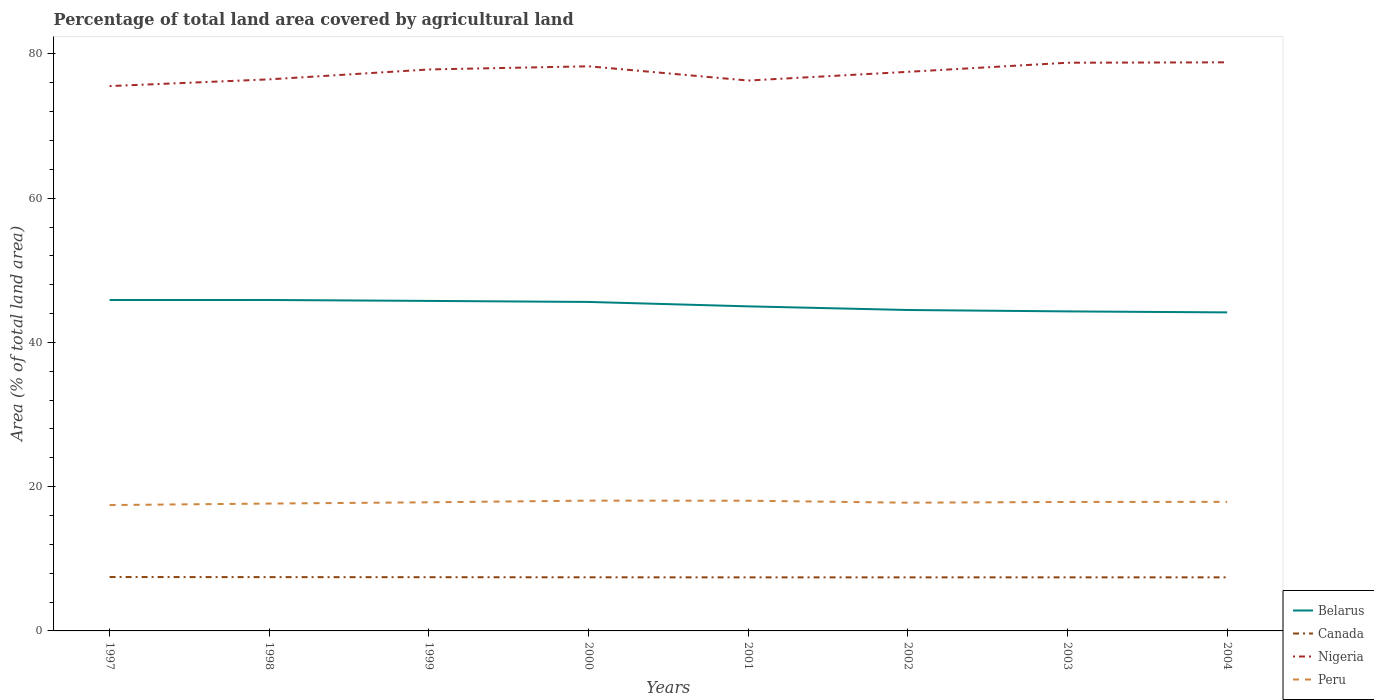Does the line corresponding to Canada intersect with the line corresponding to Peru?
Keep it short and to the point. No. Is the number of lines equal to the number of legend labels?
Keep it short and to the point. Yes. Across all years, what is the maximum percentage of agricultural land in Nigeria?
Offer a terse response. 75.54. What is the total percentage of agricultural land in Canada in the graph?
Provide a short and direct response. 0.04. What is the difference between the highest and the second highest percentage of agricultural land in Canada?
Make the answer very short. 0.05. Is the percentage of agricultural land in Peru strictly greater than the percentage of agricultural land in Canada over the years?
Make the answer very short. No. What is the difference between two consecutive major ticks on the Y-axis?
Your answer should be compact. 20. Are the values on the major ticks of Y-axis written in scientific E-notation?
Your answer should be very brief. No. What is the title of the graph?
Your answer should be very brief. Percentage of total land area covered by agricultural land. What is the label or title of the Y-axis?
Your answer should be compact. Area (% of total land area). What is the Area (% of total land area) of Belarus in 1997?
Offer a very short reply. 45.88. What is the Area (% of total land area) in Canada in 1997?
Make the answer very short. 7.47. What is the Area (% of total land area) of Nigeria in 1997?
Provide a short and direct response. 75.54. What is the Area (% of total land area) of Peru in 1997?
Give a very brief answer. 17.45. What is the Area (% of total land area) of Belarus in 1998?
Provide a succinct answer. 45.88. What is the Area (% of total land area) of Canada in 1998?
Your answer should be compact. 7.46. What is the Area (% of total land area) of Nigeria in 1998?
Give a very brief answer. 76.47. What is the Area (% of total land area) of Peru in 1998?
Ensure brevity in your answer.  17.66. What is the Area (% of total land area) of Belarus in 1999?
Ensure brevity in your answer.  45.76. What is the Area (% of total land area) of Canada in 1999?
Make the answer very short. 7.45. What is the Area (% of total land area) in Nigeria in 1999?
Your answer should be very brief. 77.85. What is the Area (% of total land area) in Peru in 1999?
Provide a succinct answer. 17.83. What is the Area (% of total land area) of Belarus in 2000?
Make the answer very short. 45.61. What is the Area (% of total land area) of Canada in 2000?
Your answer should be very brief. 7.44. What is the Area (% of total land area) of Nigeria in 2000?
Provide a succinct answer. 78.29. What is the Area (% of total land area) of Peru in 2000?
Your response must be concise. 18.07. What is the Area (% of total land area) of Belarus in 2001?
Make the answer very short. 45. What is the Area (% of total land area) in Canada in 2001?
Offer a terse response. 7.42. What is the Area (% of total land area) of Nigeria in 2001?
Make the answer very short. 76.31. What is the Area (% of total land area) in Peru in 2001?
Your answer should be compact. 18.05. What is the Area (% of total land area) in Belarus in 2002?
Give a very brief answer. 44.5. What is the Area (% of total land area) in Canada in 2002?
Provide a short and direct response. 7.42. What is the Area (% of total land area) in Nigeria in 2002?
Your response must be concise. 77.52. What is the Area (% of total land area) of Peru in 2002?
Offer a very short reply. 17.78. What is the Area (% of total land area) of Belarus in 2003?
Your response must be concise. 44.3. What is the Area (% of total land area) in Canada in 2003?
Keep it short and to the point. 7.43. What is the Area (% of total land area) of Nigeria in 2003?
Make the answer very short. 78.78. What is the Area (% of total land area) of Peru in 2003?
Give a very brief answer. 17.88. What is the Area (% of total land area) of Belarus in 2004?
Provide a short and direct response. 44.16. What is the Area (% of total land area) in Canada in 2004?
Provide a short and direct response. 7.43. What is the Area (% of total land area) in Nigeria in 2004?
Offer a terse response. 78.83. What is the Area (% of total land area) in Peru in 2004?
Make the answer very short. 17.9. Across all years, what is the maximum Area (% of total land area) of Belarus?
Provide a succinct answer. 45.88. Across all years, what is the maximum Area (% of total land area) of Canada?
Offer a terse response. 7.47. Across all years, what is the maximum Area (% of total land area) in Nigeria?
Offer a very short reply. 78.83. Across all years, what is the maximum Area (% of total land area) in Peru?
Keep it short and to the point. 18.07. Across all years, what is the minimum Area (% of total land area) in Belarus?
Ensure brevity in your answer.  44.16. Across all years, what is the minimum Area (% of total land area) of Canada?
Your answer should be very brief. 7.42. Across all years, what is the minimum Area (% of total land area) in Nigeria?
Your answer should be very brief. 75.54. Across all years, what is the minimum Area (% of total land area) of Peru?
Your answer should be very brief. 17.45. What is the total Area (% of total land area) in Belarus in the graph?
Offer a terse response. 361.09. What is the total Area (% of total land area) in Canada in the graph?
Give a very brief answer. 59.52. What is the total Area (% of total land area) of Nigeria in the graph?
Provide a succinct answer. 619.59. What is the total Area (% of total land area) of Peru in the graph?
Your response must be concise. 142.61. What is the difference between the Area (% of total land area) in Belarus in 1997 and that in 1998?
Keep it short and to the point. -0. What is the difference between the Area (% of total land area) of Canada in 1997 and that in 1998?
Provide a succinct answer. 0.01. What is the difference between the Area (% of total land area) in Nigeria in 1997 and that in 1998?
Offer a terse response. -0.93. What is the difference between the Area (% of total land area) in Peru in 1997 and that in 1998?
Offer a terse response. -0.21. What is the difference between the Area (% of total land area) in Belarus in 1997 and that in 1999?
Give a very brief answer. 0.12. What is the difference between the Area (% of total land area) of Canada in 1997 and that in 1999?
Offer a very short reply. 0.02. What is the difference between the Area (% of total land area) of Nigeria in 1997 and that in 1999?
Make the answer very short. -2.31. What is the difference between the Area (% of total land area) in Peru in 1997 and that in 1999?
Provide a succinct answer. -0.38. What is the difference between the Area (% of total land area) in Belarus in 1997 and that in 2000?
Offer a very short reply. 0.27. What is the difference between the Area (% of total land area) in Canada in 1997 and that in 2000?
Ensure brevity in your answer.  0.04. What is the difference between the Area (% of total land area) in Nigeria in 1997 and that in 2000?
Give a very brief answer. -2.74. What is the difference between the Area (% of total land area) of Peru in 1997 and that in 2000?
Give a very brief answer. -0.62. What is the difference between the Area (% of total land area) in Belarus in 1997 and that in 2001?
Ensure brevity in your answer.  0.88. What is the difference between the Area (% of total land area) in Canada in 1997 and that in 2001?
Your response must be concise. 0.05. What is the difference between the Area (% of total land area) in Nigeria in 1997 and that in 2001?
Provide a succinct answer. -0.77. What is the difference between the Area (% of total land area) in Peru in 1997 and that in 2001?
Offer a terse response. -0.6. What is the difference between the Area (% of total land area) of Belarus in 1997 and that in 2002?
Make the answer very short. 1.38. What is the difference between the Area (% of total land area) of Canada in 1997 and that in 2002?
Ensure brevity in your answer.  0.05. What is the difference between the Area (% of total land area) of Nigeria in 1997 and that in 2002?
Your response must be concise. -1.98. What is the difference between the Area (% of total land area) in Peru in 1997 and that in 2002?
Provide a short and direct response. -0.33. What is the difference between the Area (% of total land area) of Belarus in 1997 and that in 2003?
Offer a very short reply. 1.58. What is the difference between the Area (% of total land area) of Canada in 1997 and that in 2003?
Provide a short and direct response. 0.04. What is the difference between the Area (% of total land area) in Nigeria in 1997 and that in 2003?
Make the answer very short. -3.24. What is the difference between the Area (% of total land area) of Peru in 1997 and that in 2003?
Your answer should be very brief. -0.43. What is the difference between the Area (% of total land area) of Belarus in 1997 and that in 2004?
Give a very brief answer. 1.71. What is the difference between the Area (% of total land area) of Canada in 1997 and that in 2004?
Your response must be concise. 0.04. What is the difference between the Area (% of total land area) of Nigeria in 1997 and that in 2004?
Your response must be concise. -3.29. What is the difference between the Area (% of total land area) in Peru in 1997 and that in 2004?
Give a very brief answer. -0.45. What is the difference between the Area (% of total land area) in Belarus in 1998 and that in 1999?
Your answer should be very brief. 0.13. What is the difference between the Area (% of total land area) of Canada in 1998 and that in 1999?
Make the answer very short. 0.01. What is the difference between the Area (% of total land area) of Nigeria in 1998 and that in 1999?
Keep it short and to the point. -1.37. What is the difference between the Area (% of total land area) of Peru in 1998 and that in 1999?
Make the answer very short. -0.17. What is the difference between the Area (% of total land area) in Belarus in 1998 and that in 2000?
Your response must be concise. 0.27. What is the difference between the Area (% of total land area) of Canada in 1998 and that in 2000?
Make the answer very short. 0.02. What is the difference between the Area (% of total land area) in Nigeria in 1998 and that in 2000?
Keep it short and to the point. -1.81. What is the difference between the Area (% of total land area) of Peru in 1998 and that in 2000?
Provide a succinct answer. -0.41. What is the difference between the Area (% of total land area) of Belarus in 1998 and that in 2001?
Provide a short and direct response. 0.88. What is the difference between the Area (% of total land area) in Canada in 1998 and that in 2001?
Give a very brief answer. 0.04. What is the difference between the Area (% of total land area) in Nigeria in 1998 and that in 2001?
Provide a short and direct response. 0.16. What is the difference between the Area (% of total land area) in Peru in 1998 and that in 2001?
Your answer should be compact. -0.39. What is the difference between the Area (% of total land area) of Belarus in 1998 and that in 2002?
Keep it short and to the point. 1.39. What is the difference between the Area (% of total land area) in Canada in 1998 and that in 2002?
Give a very brief answer. 0.03. What is the difference between the Area (% of total land area) of Nigeria in 1998 and that in 2002?
Your answer should be very brief. -1.04. What is the difference between the Area (% of total land area) in Peru in 1998 and that in 2002?
Ensure brevity in your answer.  -0.12. What is the difference between the Area (% of total land area) of Belarus in 1998 and that in 2003?
Your answer should be very brief. 1.58. What is the difference between the Area (% of total land area) of Canada in 1998 and that in 2003?
Provide a short and direct response. 0.03. What is the difference between the Area (% of total land area) of Nigeria in 1998 and that in 2003?
Ensure brevity in your answer.  -2.31. What is the difference between the Area (% of total land area) in Peru in 1998 and that in 2003?
Your answer should be compact. -0.22. What is the difference between the Area (% of total land area) of Belarus in 1998 and that in 2004?
Provide a short and direct response. 1.72. What is the difference between the Area (% of total land area) of Canada in 1998 and that in 2004?
Provide a short and direct response. 0.03. What is the difference between the Area (% of total land area) in Nigeria in 1998 and that in 2004?
Give a very brief answer. -2.36. What is the difference between the Area (% of total land area) of Peru in 1998 and that in 2004?
Your answer should be compact. -0.24. What is the difference between the Area (% of total land area) of Belarus in 1999 and that in 2000?
Provide a short and direct response. 0.14. What is the difference between the Area (% of total land area) in Canada in 1999 and that in 2000?
Make the answer very short. 0.01. What is the difference between the Area (% of total land area) of Nigeria in 1999 and that in 2000?
Ensure brevity in your answer.  -0.44. What is the difference between the Area (% of total land area) in Peru in 1999 and that in 2000?
Provide a short and direct response. -0.23. What is the difference between the Area (% of total land area) of Belarus in 1999 and that in 2001?
Keep it short and to the point. 0.75. What is the difference between the Area (% of total land area) of Canada in 1999 and that in 2001?
Your answer should be compact. 0.02. What is the difference between the Area (% of total land area) of Nigeria in 1999 and that in 2001?
Your answer should be compact. 1.54. What is the difference between the Area (% of total land area) of Peru in 1999 and that in 2001?
Provide a succinct answer. -0.22. What is the difference between the Area (% of total land area) of Belarus in 1999 and that in 2002?
Provide a succinct answer. 1.26. What is the difference between the Area (% of total land area) of Canada in 1999 and that in 2002?
Offer a terse response. 0.02. What is the difference between the Area (% of total land area) in Nigeria in 1999 and that in 2002?
Offer a very short reply. 0.33. What is the difference between the Area (% of total land area) in Peru in 1999 and that in 2002?
Your response must be concise. 0.06. What is the difference between the Area (% of total land area) of Belarus in 1999 and that in 2003?
Your answer should be compact. 1.45. What is the difference between the Area (% of total land area) of Canada in 1999 and that in 2003?
Your answer should be compact. 0.02. What is the difference between the Area (% of total land area) of Nigeria in 1999 and that in 2003?
Give a very brief answer. -0.93. What is the difference between the Area (% of total land area) in Peru in 1999 and that in 2003?
Ensure brevity in your answer.  -0.05. What is the difference between the Area (% of total land area) in Belarus in 1999 and that in 2004?
Ensure brevity in your answer.  1.59. What is the difference between the Area (% of total land area) in Canada in 1999 and that in 2004?
Make the answer very short. 0.02. What is the difference between the Area (% of total land area) of Nigeria in 1999 and that in 2004?
Your answer should be compact. -0.99. What is the difference between the Area (% of total land area) in Peru in 1999 and that in 2004?
Offer a very short reply. -0.06. What is the difference between the Area (% of total land area) in Belarus in 2000 and that in 2001?
Offer a very short reply. 0.61. What is the difference between the Area (% of total land area) in Canada in 2000 and that in 2001?
Your answer should be very brief. 0.01. What is the difference between the Area (% of total land area) of Nigeria in 2000 and that in 2001?
Make the answer very short. 1.98. What is the difference between the Area (% of total land area) of Peru in 2000 and that in 2001?
Your answer should be very brief. 0.01. What is the difference between the Area (% of total land area) in Belarus in 2000 and that in 2002?
Provide a short and direct response. 1.12. What is the difference between the Area (% of total land area) in Canada in 2000 and that in 2002?
Give a very brief answer. 0.01. What is the difference between the Area (% of total land area) of Nigeria in 2000 and that in 2002?
Your answer should be compact. 0.77. What is the difference between the Area (% of total land area) in Peru in 2000 and that in 2002?
Your answer should be very brief. 0.29. What is the difference between the Area (% of total land area) of Belarus in 2000 and that in 2003?
Give a very brief answer. 1.31. What is the difference between the Area (% of total land area) of Canada in 2000 and that in 2003?
Give a very brief answer. 0.01. What is the difference between the Area (% of total land area) in Nigeria in 2000 and that in 2003?
Provide a short and direct response. -0.49. What is the difference between the Area (% of total land area) of Peru in 2000 and that in 2003?
Provide a short and direct response. 0.18. What is the difference between the Area (% of total land area) of Belarus in 2000 and that in 2004?
Your answer should be compact. 1.45. What is the difference between the Area (% of total land area) in Canada in 2000 and that in 2004?
Give a very brief answer. 0.01. What is the difference between the Area (% of total land area) in Nigeria in 2000 and that in 2004?
Make the answer very short. -0.55. What is the difference between the Area (% of total land area) of Peru in 2000 and that in 2004?
Make the answer very short. 0.17. What is the difference between the Area (% of total land area) in Belarus in 2001 and that in 2002?
Your answer should be compact. 0.51. What is the difference between the Area (% of total land area) of Canada in 2001 and that in 2002?
Offer a very short reply. -0. What is the difference between the Area (% of total land area) in Nigeria in 2001 and that in 2002?
Your answer should be very brief. -1.21. What is the difference between the Area (% of total land area) of Peru in 2001 and that in 2002?
Your answer should be compact. 0.28. What is the difference between the Area (% of total land area) of Belarus in 2001 and that in 2003?
Offer a terse response. 0.7. What is the difference between the Area (% of total land area) in Canada in 2001 and that in 2003?
Provide a short and direct response. -0. What is the difference between the Area (% of total land area) of Nigeria in 2001 and that in 2003?
Offer a terse response. -2.47. What is the difference between the Area (% of total land area) in Peru in 2001 and that in 2003?
Your response must be concise. 0.17. What is the difference between the Area (% of total land area) in Belarus in 2001 and that in 2004?
Offer a very short reply. 0.84. What is the difference between the Area (% of total land area) of Canada in 2001 and that in 2004?
Keep it short and to the point. -0.01. What is the difference between the Area (% of total land area) in Nigeria in 2001 and that in 2004?
Ensure brevity in your answer.  -2.53. What is the difference between the Area (% of total land area) of Peru in 2001 and that in 2004?
Your answer should be compact. 0.16. What is the difference between the Area (% of total land area) of Belarus in 2002 and that in 2003?
Provide a succinct answer. 0.19. What is the difference between the Area (% of total land area) of Canada in 2002 and that in 2003?
Make the answer very short. -0. What is the difference between the Area (% of total land area) in Nigeria in 2002 and that in 2003?
Provide a succinct answer. -1.26. What is the difference between the Area (% of total land area) of Peru in 2002 and that in 2003?
Your answer should be compact. -0.1. What is the difference between the Area (% of total land area) of Belarus in 2002 and that in 2004?
Your response must be concise. 0.33. What is the difference between the Area (% of total land area) in Canada in 2002 and that in 2004?
Keep it short and to the point. -0. What is the difference between the Area (% of total land area) in Nigeria in 2002 and that in 2004?
Your answer should be very brief. -1.32. What is the difference between the Area (% of total land area) of Peru in 2002 and that in 2004?
Provide a short and direct response. -0.12. What is the difference between the Area (% of total land area) of Belarus in 2003 and that in 2004?
Your response must be concise. 0.14. What is the difference between the Area (% of total land area) of Canada in 2003 and that in 2004?
Offer a terse response. -0. What is the difference between the Area (% of total land area) of Nigeria in 2003 and that in 2004?
Your answer should be very brief. -0.05. What is the difference between the Area (% of total land area) in Peru in 2003 and that in 2004?
Offer a terse response. -0.01. What is the difference between the Area (% of total land area) in Belarus in 1997 and the Area (% of total land area) in Canada in 1998?
Your answer should be compact. 38.42. What is the difference between the Area (% of total land area) in Belarus in 1997 and the Area (% of total land area) in Nigeria in 1998?
Provide a succinct answer. -30.6. What is the difference between the Area (% of total land area) in Belarus in 1997 and the Area (% of total land area) in Peru in 1998?
Your answer should be compact. 28.22. What is the difference between the Area (% of total land area) of Canada in 1997 and the Area (% of total land area) of Nigeria in 1998?
Your answer should be compact. -69. What is the difference between the Area (% of total land area) in Canada in 1997 and the Area (% of total land area) in Peru in 1998?
Make the answer very short. -10.19. What is the difference between the Area (% of total land area) in Nigeria in 1997 and the Area (% of total land area) in Peru in 1998?
Give a very brief answer. 57.88. What is the difference between the Area (% of total land area) in Belarus in 1997 and the Area (% of total land area) in Canada in 1999?
Make the answer very short. 38.43. What is the difference between the Area (% of total land area) of Belarus in 1997 and the Area (% of total land area) of Nigeria in 1999?
Make the answer very short. -31.97. What is the difference between the Area (% of total land area) in Belarus in 1997 and the Area (% of total land area) in Peru in 1999?
Your answer should be very brief. 28.05. What is the difference between the Area (% of total land area) of Canada in 1997 and the Area (% of total land area) of Nigeria in 1999?
Offer a very short reply. -70.37. What is the difference between the Area (% of total land area) of Canada in 1997 and the Area (% of total land area) of Peru in 1999?
Keep it short and to the point. -10.36. What is the difference between the Area (% of total land area) in Nigeria in 1997 and the Area (% of total land area) in Peru in 1999?
Offer a terse response. 57.71. What is the difference between the Area (% of total land area) in Belarus in 1997 and the Area (% of total land area) in Canada in 2000?
Provide a short and direct response. 38.44. What is the difference between the Area (% of total land area) of Belarus in 1997 and the Area (% of total land area) of Nigeria in 2000?
Offer a terse response. -32.41. What is the difference between the Area (% of total land area) of Belarus in 1997 and the Area (% of total land area) of Peru in 2000?
Your answer should be compact. 27.81. What is the difference between the Area (% of total land area) in Canada in 1997 and the Area (% of total land area) in Nigeria in 2000?
Give a very brief answer. -70.81. What is the difference between the Area (% of total land area) in Canada in 1997 and the Area (% of total land area) in Peru in 2000?
Provide a succinct answer. -10.59. What is the difference between the Area (% of total land area) of Nigeria in 1997 and the Area (% of total land area) of Peru in 2000?
Offer a very short reply. 57.47. What is the difference between the Area (% of total land area) in Belarus in 1997 and the Area (% of total land area) in Canada in 2001?
Your response must be concise. 38.46. What is the difference between the Area (% of total land area) of Belarus in 1997 and the Area (% of total land area) of Nigeria in 2001?
Provide a succinct answer. -30.43. What is the difference between the Area (% of total land area) of Belarus in 1997 and the Area (% of total land area) of Peru in 2001?
Give a very brief answer. 27.83. What is the difference between the Area (% of total land area) in Canada in 1997 and the Area (% of total land area) in Nigeria in 2001?
Your response must be concise. -68.84. What is the difference between the Area (% of total land area) in Canada in 1997 and the Area (% of total land area) in Peru in 2001?
Provide a succinct answer. -10.58. What is the difference between the Area (% of total land area) of Nigeria in 1997 and the Area (% of total land area) of Peru in 2001?
Offer a very short reply. 57.49. What is the difference between the Area (% of total land area) in Belarus in 1997 and the Area (% of total land area) in Canada in 2002?
Give a very brief answer. 38.45. What is the difference between the Area (% of total land area) in Belarus in 1997 and the Area (% of total land area) in Nigeria in 2002?
Give a very brief answer. -31.64. What is the difference between the Area (% of total land area) in Belarus in 1997 and the Area (% of total land area) in Peru in 2002?
Give a very brief answer. 28.1. What is the difference between the Area (% of total land area) of Canada in 1997 and the Area (% of total land area) of Nigeria in 2002?
Offer a terse response. -70.05. What is the difference between the Area (% of total land area) in Canada in 1997 and the Area (% of total land area) in Peru in 2002?
Your answer should be compact. -10.31. What is the difference between the Area (% of total land area) of Nigeria in 1997 and the Area (% of total land area) of Peru in 2002?
Offer a terse response. 57.76. What is the difference between the Area (% of total land area) of Belarus in 1997 and the Area (% of total land area) of Canada in 2003?
Offer a terse response. 38.45. What is the difference between the Area (% of total land area) in Belarus in 1997 and the Area (% of total land area) in Nigeria in 2003?
Give a very brief answer. -32.9. What is the difference between the Area (% of total land area) of Belarus in 1997 and the Area (% of total land area) of Peru in 2003?
Your answer should be very brief. 28. What is the difference between the Area (% of total land area) in Canada in 1997 and the Area (% of total land area) in Nigeria in 2003?
Ensure brevity in your answer.  -71.31. What is the difference between the Area (% of total land area) in Canada in 1997 and the Area (% of total land area) in Peru in 2003?
Offer a very short reply. -10.41. What is the difference between the Area (% of total land area) of Nigeria in 1997 and the Area (% of total land area) of Peru in 2003?
Keep it short and to the point. 57.66. What is the difference between the Area (% of total land area) of Belarus in 1997 and the Area (% of total land area) of Canada in 2004?
Offer a very short reply. 38.45. What is the difference between the Area (% of total land area) in Belarus in 1997 and the Area (% of total land area) in Nigeria in 2004?
Your response must be concise. -32.96. What is the difference between the Area (% of total land area) of Belarus in 1997 and the Area (% of total land area) of Peru in 2004?
Give a very brief answer. 27.98. What is the difference between the Area (% of total land area) of Canada in 1997 and the Area (% of total land area) of Nigeria in 2004?
Your answer should be compact. -71.36. What is the difference between the Area (% of total land area) of Canada in 1997 and the Area (% of total land area) of Peru in 2004?
Offer a terse response. -10.42. What is the difference between the Area (% of total land area) in Nigeria in 1997 and the Area (% of total land area) in Peru in 2004?
Keep it short and to the point. 57.65. What is the difference between the Area (% of total land area) of Belarus in 1998 and the Area (% of total land area) of Canada in 1999?
Your answer should be very brief. 38.44. What is the difference between the Area (% of total land area) in Belarus in 1998 and the Area (% of total land area) in Nigeria in 1999?
Give a very brief answer. -31.96. What is the difference between the Area (% of total land area) in Belarus in 1998 and the Area (% of total land area) in Peru in 1999?
Offer a very short reply. 28.05. What is the difference between the Area (% of total land area) of Canada in 1998 and the Area (% of total land area) of Nigeria in 1999?
Offer a very short reply. -70.39. What is the difference between the Area (% of total land area) in Canada in 1998 and the Area (% of total land area) in Peru in 1999?
Offer a very short reply. -10.37. What is the difference between the Area (% of total land area) in Nigeria in 1998 and the Area (% of total land area) in Peru in 1999?
Give a very brief answer. 58.64. What is the difference between the Area (% of total land area) in Belarus in 1998 and the Area (% of total land area) in Canada in 2000?
Ensure brevity in your answer.  38.45. What is the difference between the Area (% of total land area) in Belarus in 1998 and the Area (% of total land area) in Nigeria in 2000?
Your response must be concise. -32.4. What is the difference between the Area (% of total land area) of Belarus in 1998 and the Area (% of total land area) of Peru in 2000?
Give a very brief answer. 27.82. What is the difference between the Area (% of total land area) of Canada in 1998 and the Area (% of total land area) of Nigeria in 2000?
Your answer should be compact. -70.83. What is the difference between the Area (% of total land area) of Canada in 1998 and the Area (% of total land area) of Peru in 2000?
Offer a very short reply. -10.61. What is the difference between the Area (% of total land area) in Nigeria in 1998 and the Area (% of total land area) in Peru in 2000?
Ensure brevity in your answer.  58.41. What is the difference between the Area (% of total land area) of Belarus in 1998 and the Area (% of total land area) of Canada in 2001?
Your answer should be compact. 38.46. What is the difference between the Area (% of total land area) of Belarus in 1998 and the Area (% of total land area) of Nigeria in 2001?
Provide a succinct answer. -30.43. What is the difference between the Area (% of total land area) of Belarus in 1998 and the Area (% of total land area) of Peru in 2001?
Offer a very short reply. 27.83. What is the difference between the Area (% of total land area) in Canada in 1998 and the Area (% of total land area) in Nigeria in 2001?
Provide a short and direct response. -68.85. What is the difference between the Area (% of total land area) of Canada in 1998 and the Area (% of total land area) of Peru in 2001?
Make the answer very short. -10.59. What is the difference between the Area (% of total land area) of Nigeria in 1998 and the Area (% of total land area) of Peru in 2001?
Give a very brief answer. 58.42. What is the difference between the Area (% of total land area) in Belarus in 1998 and the Area (% of total land area) in Canada in 2002?
Ensure brevity in your answer.  38.46. What is the difference between the Area (% of total land area) in Belarus in 1998 and the Area (% of total land area) in Nigeria in 2002?
Provide a short and direct response. -31.63. What is the difference between the Area (% of total land area) of Belarus in 1998 and the Area (% of total land area) of Peru in 2002?
Make the answer very short. 28.11. What is the difference between the Area (% of total land area) in Canada in 1998 and the Area (% of total land area) in Nigeria in 2002?
Your answer should be very brief. -70.06. What is the difference between the Area (% of total land area) in Canada in 1998 and the Area (% of total land area) in Peru in 2002?
Your answer should be compact. -10.32. What is the difference between the Area (% of total land area) of Nigeria in 1998 and the Area (% of total land area) of Peru in 2002?
Provide a succinct answer. 58.7. What is the difference between the Area (% of total land area) of Belarus in 1998 and the Area (% of total land area) of Canada in 2003?
Give a very brief answer. 38.46. What is the difference between the Area (% of total land area) in Belarus in 1998 and the Area (% of total land area) in Nigeria in 2003?
Give a very brief answer. -32.9. What is the difference between the Area (% of total land area) of Belarus in 1998 and the Area (% of total land area) of Peru in 2003?
Your answer should be very brief. 28. What is the difference between the Area (% of total land area) in Canada in 1998 and the Area (% of total land area) in Nigeria in 2003?
Offer a terse response. -71.32. What is the difference between the Area (% of total land area) in Canada in 1998 and the Area (% of total land area) in Peru in 2003?
Your answer should be very brief. -10.42. What is the difference between the Area (% of total land area) in Nigeria in 1998 and the Area (% of total land area) in Peru in 2003?
Make the answer very short. 58.59. What is the difference between the Area (% of total land area) of Belarus in 1998 and the Area (% of total land area) of Canada in 2004?
Your answer should be very brief. 38.45. What is the difference between the Area (% of total land area) in Belarus in 1998 and the Area (% of total land area) in Nigeria in 2004?
Give a very brief answer. -32.95. What is the difference between the Area (% of total land area) in Belarus in 1998 and the Area (% of total land area) in Peru in 2004?
Your answer should be compact. 27.99. What is the difference between the Area (% of total land area) of Canada in 1998 and the Area (% of total land area) of Nigeria in 2004?
Offer a terse response. -71.37. What is the difference between the Area (% of total land area) of Canada in 1998 and the Area (% of total land area) of Peru in 2004?
Your answer should be compact. -10.44. What is the difference between the Area (% of total land area) in Nigeria in 1998 and the Area (% of total land area) in Peru in 2004?
Offer a terse response. 58.58. What is the difference between the Area (% of total land area) of Belarus in 1999 and the Area (% of total land area) of Canada in 2000?
Your answer should be compact. 38.32. What is the difference between the Area (% of total land area) in Belarus in 1999 and the Area (% of total land area) in Nigeria in 2000?
Make the answer very short. -32.53. What is the difference between the Area (% of total land area) in Belarus in 1999 and the Area (% of total land area) in Peru in 2000?
Provide a succinct answer. 27.69. What is the difference between the Area (% of total land area) of Canada in 1999 and the Area (% of total land area) of Nigeria in 2000?
Provide a short and direct response. -70.84. What is the difference between the Area (% of total land area) of Canada in 1999 and the Area (% of total land area) of Peru in 2000?
Your response must be concise. -10.62. What is the difference between the Area (% of total land area) in Nigeria in 1999 and the Area (% of total land area) in Peru in 2000?
Your answer should be very brief. 59.78. What is the difference between the Area (% of total land area) of Belarus in 1999 and the Area (% of total land area) of Canada in 2001?
Offer a very short reply. 38.33. What is the difference between the Area (% of total land area) in Belarus in 1999 and the Area (% of total land area) in Nigeria in 2001?
Your answer should be compact. -30.55. What is the difference between the Area (% of total land area) in Belarus in 1999 and the Area (% of total land area) in Peru in 2001?
Your answer should be compact. 27.7. What is the difference between the Area (% of total land area) of Canada in 1999 and the Area (% of total land area) of Nigeria in 2001?
Ensure brevity in your answer.  -68.86. What is the difference between the Area (% of total land area) of Canada in 1999 and the Area (% of total land area) of Peru in 2001?
Make the answer very short. -10.6. What is the difference between the Area (% of total land area) of Nigeria in 1999 and the Area (% of total land area) of Peru in 2001?
Keep it short and to the point. 59.79. What is the difference between the Area (% of total land area) in Belarus in 1999 and the Area (% of total land area) in Canada in 2002?
Your response must be concise. 38.33. What is the difference between the Area (% of total land area) of Belarus in 1999 and the Area (% of total land area) of Nigeria in 2002?
Offer a very short reply. -31.76. What is the difference between the Area (% of total land area) in Belarus in 1999 and the Area (% of total land area) in Peru in 2002?
Ensure brevity in your answer.  27.98. What is the difference between the Area (% of total land area) in Canada in 1999 and the Area (% of total land area) in Nigeria in 2002?
Your answer should be very brief. -70.07. What is the difference between the Area (% of total land area) in Canada in 1999 and the Area (% of total land area) in Peru in 2002?
Offer a very short reply. -10.33. What is the difference between the Area (% of total land area) of Nigeria in 1999 and the Area (% of total land area) of Peru in 2002?
Your answer should be very brief. 60.07. What is the difference between the Area (% of total land area) of Belarus in 1999 and the Area (% of total land area) of Canada in 2003?
Make the answer very short. 38.33. What is the difference between the Area (% of total land area) in Belarus in 1999 and the Area (% of total land area) in Nigeria in 2003?
Provide a short and direct response. -33.02. What is the difference between the Area (% of total land area) of Belarus in 1999 and the Area (% of total land area) of Peru in 2003?
Your answer should be very brief. 27.87. What is the difference between the Area (% of total land area) in Canada in 1999 and the Area (% of total land area) in Nigeria in 2003?
Offer a very short reply. -71.33. What is the difference between the Area (% of total land area) in Canada in 1999 and the Area (% of total land area) in Peru in 2003?
Ensure brevity in your answer.  -10.43. What is the difference between the Area (% of total land area) in Nigeria in 1999 and the Area (% of total land area) in Peru in 2003?
Provide a short and direct response. 59.97. What is the difference between the Area (% of total land area) in Belarus in 1999 and the Area (% of total land area) in Canada in 2004?
Your answer should be very brief. 38.33. What is the difference between the Area (% of total land area) of Belarus in 1999 and the Area (% of total land area) of Nigeria in 2004?
Provide a short and direct response. -33.08. What is the difference between the Area (% of total land area) of Belarus in 1999 and the Area (% of total land area) of Peru in 2004?
Your response must be concise. 27.86. What is the difference between the Area (% of total land area) of Canada in 1999 and the Area (% of total land area) of Nigeria in 2004?
Ensure brevity in your answer.  -71.39. What is the difference between the Area (% of total land area) in Canada in 1999 and the Area (% of total land area) in Peru in 2004?
Provide a succinct answer. -10.45. What is the difference between the Area (% of total land area) of Nigeria in 1999 and the Area (% of total land area) of Peru in 2004?
Provide a succinct answer. 59.95. What is the difference between the Area (% of total land area) of Belarus in 2000 and the Area (% of total land area) of Canada in 2001?
Provide a succinct answer. 38.19. What is the difference between the Area (% of total land area) in Belarus in 2000 and the Area (% of total land area) in Nigeria in 2001?
Provide a short and direct response. -30.7. What is the difference between the Area (% of total land area) of Belarus in 2000 and the Area (% of total land area) of Peru in 2001?
Your answer should be very brief. 27.56. What is the difference between the Area (% of total land area) of Canada in 2000 and the Area (% of total land area) of Nigeria in 2001?
Offer a very short reply. -68.87. What is the difference between the Area (% of total land area) of Canada in 2000 and the Area (% of total land area) of Peru in 2001?
Ensure brevity in your answer.  -10.62. What is the difference between the Area (% of total land area) in Nigeria in 2000 and the Area (% of total land area) in Peru in 2001?
Offer a very short reply. 60.23. What is the difference between the Area (% of total land area) in Belarus in 2000 and the Area (% of total land area) in Canada in 2002?
Offer a terse response. 38.19. What is the difference between the Area (% of total land area) of Belarus in 2000 and the Area (% of total land area) of Nigeria in 2002?
Make the answer very short. -31.9. What is the difference between the Area (% of total land area) of Belarus in 2000 and the Area (% of total land area) of Peru in 2002?
Your answer should be compact. 27.84. What is the difference between the Area (% of total land area) of Canada in 2000 and the Area (% of total land area) of Nigeria in 2002?
Keep it short and to the point. -70.08. What is the difference between the Area (% of total land area) of Canada in 2000 and the Area (% of total land area) of Peru in 2002?
Offer a terse response. -10.34. What is the difference between the Area (% of total land area) in Nigeria in 2000 and the Area (% of total land area) in Peru in 2002?
Give a very brief answer. 60.51. What is the difference between the Area (% of total land area) of Belarus in 2000 and the Area (% of total land area) of Canada in 2003?
Keep it short and to the point. 38.19. What is the difference between the Area (% of total land area) in Belarus in 2000 and the Area (% of total land area) in Nigeria in 2003?
Ensure brevity in your answer.  -33.17. What is the difference between the Area (% of total land area) in Belarus in 2000 and the Area (% of total land area) in Peru in 2003?
Your answer should be compact. 27.73. What is the difference between the Area (% of total land area) of Canada in 2000 and the Area (% of total land area) of Nigeria in 2003?
Make the answer very short. -71.34. What is the difference between the Area (% of total land area) in Canada in 2000 and the Area (% of total land area) in Peru in 2003?
Provide a short and direct response. -10.45. What is the difference between the Area (% of total land area) in Nigeria in 2000 and the Area (% of total land area) in Peru in 2003?
Your answer should be very brief. 60.4. What is the difference between the Area (% of total land area) of Belarus in 2000 and the Area (% of total land area) of Canada in 2004?
Your answer should be compact. 38.18. What is the difference between the Area (% of total land area) of Belarus in 2000 and the Area (% of total land area) of Nigeria in 2004?
Make the answer very short. -33.22. What is the difference between the Area (% of total land area) of Belarus in 2000 and the Area (% of total land area) of Peru in 2004?
Your answer should be very brief. 27.72. What is the difference between the Area (% of total land area) of Canada in 2000 and the Area (% of total land area) of Nigeria in 2004?
Give a very brief answer. -71.4. What is the difference between the Area (% of total land area) of Canada in 2000 and the Area (% of total land area) of Peru in 2004?
Your response must be concise. -10.46. What is the difference between the Area (% of total land area) in Nigeria in 2000 and the Area (% of total land area) in Peru in 2004?
Ensure brevity in your answer.  60.39. What is the difference between the Area (% of total land area) of Belarus in 2001 and the Area (% of total land area) of Canada in 2002?
Offer a terse response. 37.58. What is the difference between the Area (% of total land area) in Belarus in 2001 and the Area (% of total land area) in Nigeria in 2002?
Give a very brief answer. -32.52. What is the difference between the Area (% of total land area) in Belarus in 2001 and the Area (% of total land area) in Peru in 2002?
Provide a succinct answer. 27.22. What is the difference between the Area (% of total land area) in Canada in 2001 and the Area (% of total land area) in Nigeria in 2002?
Your answer should be very brief. -70.09. What is the difference between the Area (% of total land area) in Canada in 2001 and the Area (% of total land area) in Peru in 2002?
Make the answer very short. -10.35. What is the difference between the Area (% of total land area) in Nigeria in 2001 and the Area (% of total land area) in Peru in 2002?
Make the answer very short. 58.53. What is the difference between the Area (% of total land area) of Belarus in 2001 and the Area (% of total land area) of Canada in 2003?
Offer a terse response. 37.57. What is the difference between the Area (% of total land area) in Belarus in 2001 and the Area (% of total land area) in Nigeria in 2003?
Offer a terse response. -33.78. What is the difference between the Area (% of total land area) of Belarus in 2001 and the Area (% of total land area) of Peru in 2003?
Your answer should be compact. 27.12. What is the difference between the Area (% of total land area) in Canada in 2001 and the Area (% of total land area) in Nigeria in 2003?
Keep it short and to the point. -71.36. What is the difference between the Area (% of total land area) of Canada in 2001 and the Area (% of total land area) of Peru in 2003?
Give a very brief answer. -10.46. What is the difference between the Area (% of total land area) of Nigeria in 2001 and the Area (% of total land area) of Peru in 2003?
Your answer should be compact. 58.43. What is the difference between the Area (% of total land area) of Belarus in 2001 and the Area (% of total land area) of Canada in 2004?
Provide a succinct answer. 37.57. What is the difference between the Area (% of total land area) in Belarus in 2001 and the Area (% of total land area) in Nigeria in 2004?
Make the answer very short. -33.83. What is the difference between the Area (% of total land area) in Belarus in 2001 and the Area (% of total land area) in Peru in 2004?
Your response must be concise. 27.11. What is the difference between the Area (% of total land area) in Canada in 2001 and the Area (% of total land area) in Nigeria in 2004?
Give a very brief answer. -71.41. What is the difference between the Area (% of total land area) of Canada in 2001 and the Area (% of total land area) of Peru in 2004?
Ensure brevity in your answer.  -10.47. What is the difference between the Area (% of total land area) in Nigeria in 2001 and the Area (% of total land area) in Peru in 2004?
Your response must be concise. 58.41. What is the difference between the Area (% of total land area) of Belarus in 2002 and the Area (% of total land area) of Canada in 2003?
Offer a very short reply. 37.07. What is the difference between the Area (% of total land area) in Belarus in 2002 and the Area (% of total land area) in Nigeria in 2003?
Your answer should be compact. -34.28. What is the difference between the Area (% of total land area) of Belarus in 2002 and the Area (% of total land area) of Peru in 2003?
Offer a very short reply. 26.61. What is the difference between the Area (% of total land area) in Canada in 2002 and the Area (% of total land area) in Nigeria in 2003?
Provide a succinct answer. -71.35. What is the difference between the Area (% of total land area) of Canada in 2002 and the Area (% of total land area) of Peru in 2003?
Your response must be concise. -10.46. What is the difference between the Area (% of total land area) of Nigeria in 2002 and the Area (% of total land area) of Peru in 2003?
Your response must be concise. 59.64. What is the difference between the Area (% of total land area) of Belarus in 2002 and the Area (% of total land area) of Canada in 2004?
Make the answer very short. 37.07. What is the difference between the Area (% of total land area) of Belarus in 2002 and the Area (% of total land area) of Nigeria in 2004?
Make the answer very short. -34.34. What is the difference between the Area (% of total land area) in Belarus in 2002 and the Area (% of total land area) in Peru in 2004?
Your response must be concise. 26.6. What is the difference between the Area (% of total land area) of Canada in 2002 and the Area (% of total land area) of Nigeria in 2004?
Give a very brief answer. -71.41. What is the difference between the Area (% of total land area) of Canada in 2002 and the Area (% of total land area) of Peru in 2004?
Give a very brief answer. -10.47. What is the difference between the Area (% of total land area) of Nigeria in 2002 and the Area (% of total land area) of Peru in 2004?
Give a very brief answer. 59.62. What is the difference between the Area (% of total land area) in Belarus in 2003 and the Area (% of total land area) in Canada in 2004?
Keep it short and to the point. 36.87. What is the difference between the Area (% of total land area) in Belarus in 2003 and the Area (% of total land area) in Nigeria in 2004?
Offer a terse response. -34.53. What is the difference between the Area (% of total land area) of Belarus in 2003 and the Area (% of total land area) of Peru in 2004?
Offer a terse response. 26.41. What is the difference between the Area (% of total land area) in Canada in 2003 and the Area (% of total land area) in Nigeria in 2004?
Offer a terse response. -71.41. What is the difference between the Area (% of total land area) of Canada in 2003 and the Area (% of total land area) of Peru in 2004?
Ensure brevity in your answer.  -10.47. What is the difference between the Area (% of total land area) in Nigeria in 2003 and the Area (% of total land area) in Peru in 2004?
Keep it short and to the point. 60.88. What is the average Area (% of total land area) in Belarus per year?
Provide a succinct answer. 45.14. What is the average Area (% of total land area) in Canada per year?
Your answer should be compact. 7.44. What is the average Area (% of total land area) of Nigeria per year?
Provide a short and direct response. 77.45. What is the average Area (% of total land area) of Peru per year?
Your answer should be very brief. 17.83. In the year 1997, what is the difference between the Area (% of total land area) of Belarus and Area (% of total land area) of Canada?
Offer a terse response. 38.41. In the year 1997, what is the difference between the Area (% of total land area) in Belarus and Area (% of total land area) in Nigeria?
Your answer should be very brief. -29.66. In the year 1997, what is the difference between the Area (% of total land area) of Belarus and Area (% of total land area) of Peru?
Your answer should be very brief. 28.43. In the year 1997, what is the difference between the Area (% of total land area) of Canada and Area (% of total land area) of Nigeria?
Your response must be concise. -68.07. In the year 1997, what is the difference between the Area (% of total land area) in Canada and Area (% of total land area) in Peru?
Ensure brevity in your answer.  -9.98. In the year 1997, what is the difference between the Area (% of total land area) in Nigeria and Area (% of total land area) in Peru?
Provide a short and direct response. 58.09. In the year 1998, what is the difference between the Area (% of total land area) of Belarus and Area (% of total land area) of Canada?
Keep it short and to the point. 38.42. In the year 1998, what is the difference between the Area (% of total land area) of Belarus and Area (% of total land area) of Nigeria?
Provide a short and direct response. -30.59. In the year 1998, what is the difference between the Area (% of total land area) in Belarus and Area (% of total land area) in Peru?
Your answer should be very brief. 28.22. In the year 1998, what is the difference between the Area (% of total land area) of Canada and Area (% of total land area) of Nigeria?
Make the answer very short. -69.01. In the year 1998, what is the difference between the Area (% of total land area) of Canada and Area (% of total land area) of Peru?
Your answer should be very brief. -10.2. In the year 1998, what is the difference between the Area (% of total land area) in Nigeria and Area (% of total land area) in Peru?
Your response must be concise. 58.82. In the year 1999, what is the difference between the Area (% of total land area) in Belarus and Area (% of total land area) in Canada?
Ensure brevity in your answer.  38.31. In the year 1999, what is the difference between the Area (% of total land area) of Belarus and Area (% of total land area) of Nigeria?
Your answer should be compact. -32.09. In the year 1999, what is the difference between the Area (% of total land area) in Belarus and Area (% of total land area) in Peru?
Make the answer very short. 27.92. In the year 1999, what is the difference between the Area (% of total land area) of Canada and Area (% of total land area) of Nigeria?
Make the answer very short. -70.4. In the year 1999, what is the difference between the Area (% of total land area) of Canada and Area (% of total land area) of Peru?
Your answer should be compact. -10.39. In the year 1999, what is the difference between the Area (% of total land area) of Nigeria and Area (% of total land area) of Peru?
Ensure brevity in your answer.  60.01. In the year 2000, what is the difference between the Area (% of total land area) in Belarus and Area (% of total land area) in Canada?
Offer a very short reply. 38.18. In the year 2000, what is the difference between the Area (% of total land area) of Belarus and Area (% of total land area) of Nigeria?
Ensure brevity in your answer.  -32.67. In the year 2000, what is the difference between the Area (% of total land area) of Belarus and Area (% of total land area) of Peru?
Keep it short and to the point. 27.55. In the year 2000, what is the difference between the Area (% of total land area) of Canada and Area (% of total land area) of Nigeria?
Your response must be concise. -70.85. In the year 2000, what is the difference between the Area (% of total land area) in Canada and Area (% of total land area) in Peru?
Give a very brief answer. -10.63. In the year 2000, what is the difference between the Area (% of total land area) of Nigeria and Area (% of total land area) of Peru?
Offer a terse response. 60.22. In the year 2001, what is the difference between the Area (% of total land area) of Belarus and Area (% of total land area) of Canada?
Provide a short and direct response. 37.58. In the year 2001, what is the difference between the Area (% of total land area) in Belarus and Area (% of total land area) in Nigeria?
Your response must be concise. -31.31. In the year 2001, what is the difference between the Area (% of total land area) in Belarus and Area (% of total land area) in Peru?
Your response must be concise. 26.95. In the year 2001, what is the difference between the Area (% of total land area) of Canada and Area (% of total land area) of Nigeria?
Keep it short and to the point. -68.89. In the year 2001, what is the difference between the Area (% of total land area) in Canada and Area (% of total land area) in Peru?
Your answer should be compact. -10.63. In the year 2001, what is the difference between the Area (% of total land area) of Nigeria and Area (% of total land area) of Peru?
Offer a very short reply. 58.26. In the year 2002, what is the difference between the Area (% of total land area) of Belarus and Area (% of total land area) of Canada?
Provide a short and direct response. 37.07. In the year 2002, what is the difference between the Area (% of total land area) in Belarus and Area (% of total land area) in Nigeria?
Provide a short and direct response. -33.02. In the year 2002, what is the difference between the Area (% of total land area) in Belarus and Area (% of total land area) in Peru?
Provide a short and direct response. 26.72. In the year 2002, what is the difference between the Area (% of total land area) of Canada and Area (% of total land area) of Nigeria?
Ensure brevity in your answer.  -70.09. In the year 2002, what is the difference between the Area (% of total land area) in Canada and Area (% of total land area) in Peru?
Your response must be concise. -10.35. In the year 2002, what is the difference between the Area (% of total land area) in Nigeria and Area (% of total land area) in Peru?
Give a very brief answer. 59.74. In the year 2003, what is the difference between the Area (% of total land area) in Belarus and Area (% of total land area) in Canada?
Your answer should be very brief. 36.88. In the year 2003, what is the difference between the Area (% of total land area) of Belarus and Area (% of total land area) of Nigeria?
Keep it short and to the point. -34.48. In the year 2003, what is the difference between the Area (% of total land area) in Belarus and Area (% of total land area) in Peru?
Make the answer very short. 26.42. In the year 2003, what is the difference between the Area (% of total land area) of Canada and Area (% of total land area) of Nigeria?
Ensure brevity in your answer.  -71.35. In the year 2003, what is the difference between the Area (% of total land area) in Canada and Area (% of total land area) in Peru?
Provide a short and direct response. -10.45. In the year 2003, what is the difference between the Area (% of total land area) in Nigeria and Area (% of total land area) in Peru?
Your answer should be very brief. 60.9. In the year 2004, what is the difference between the Area (% of total land area) of Belarus and Area (% of total land area) of Canada?
Offer a terse response. 36.74. In the year 2004, what is the difference between the Area (% of total land area) of Belarus and Area (% of total land area) of Nigeria?
Ensure brevity in your answer.  -34.67. In the year 2004, what is the difference between the Area (% of total land area) of Belarus and Area (% of total land area) of Peru?
Your response must be concise. 26.27. In the year 2004, what is the difference between the Area (% of total land area) in Canada and Area (% of total land area) in Nigeria?
Keep it short and to the point. -71.41. In the year 2004, what is the difference between the Area (% of total land area) in Canada and Area (% of total land area) in Peru?
Make the answer very short. -10.47. In the year 2004, what is the difference between the Area (% of total land area) in Nigeria and Area (% of total land area) in Peru?
Give a very brief answer. 60.94. What is the ratio of the Area (% of total land area) in Canada in 1997 to that in 1999?
Your answer should be very brief. 1. What is the ratio of the Area (% of total land area) in Nigeria in 1997 to that in 1999?
Provide a succinct answer. 0.97. What is the ratio of the Area (% of total land area) in Peru in 1997 to that in 1999?
Keep it short and to the point. 0.98. What is the ratio of the Area (% of total land area) in Nigeria in 1997 to that in 2000?
Provide a succinct answer. 0.96. What is the ratio of the Area (% of total land area) in Peru in 1997 to that in 2000?
Make the answer very short. 0.97. What is the ratio of the Area (% of total land area) of Belarus in 1997 to that in 2001?
Make the answer very short. 1.02. What is the ratio of the Area (% of total land area) in Peru in 1997 to that in 2001?
Give a very brief answer. 0.97. What is the ratio of the Area (% of total land area) of Belarus in 1997 to that in 2002?
Offer a very short reply. 1.03. What is the ratio of the Area (% of total land area) in Nigeria in 1997 to that in 2002?
Offer a terse response. 0.97. What is the ratio of the Area (% of total land area) of Peru in 1997 to that in 2002?
Your response must be concise. 0.98. What is the ratio of the Area (% of total land area) of Belarus in 1997 to that in 2003?
Offer a terse response. 1.04. What is the ratio of the Area (% of total land area) in Canada in 1997 to that in 2003?
Keep it short and to the point. 1.01. What is the ratio of the Area (% of total land area) of Nigeria in 1997 to that in 2003?
Your answer should be very brief. 0.96. What is the ratio of the Area (% of total land area) of Peru in 1997 to that in 2003?
Offer a very short reply. 0.98. What is the ratio of the Area (% of total land area) in Belarus in 1997 to that in 2004?
Your answer should be compact. 1.04. What is the ratio of the Area (% of total land area) of Canada in 1997 to that in 2004?
Give a very brief answer. 1.01. What is the ratio of the Area (% of total land area) in Nigeria in 1997 to that in 2004?
Provide a succinct answer. 0.96. What is the ratio of the Area (% of total land area) of Peru in 1997 to that in 2004?
Provide a succinct answer. 0.98. What is the ratio of the Area (% of total land area) in Belarus in 1998 to that in 1999?
Your response must be concise. 1. What is the ratio of the Area (% of total land area) of Canada in 1998 to that in 1999?
Offer a very short reply. 1. What is the ratio of the Area (% of total land area) in Nigeria in 1998 to that in 1999?
Give a very brief answer. 0.98. What is the ratio of the Area (% of total land area) of Peru in 1998 to that in 1999?
Offer a very short reply. 0.99. What is the ratio of the Area (% of total land area) in Belarus in 1998 to that in 2000?
Provide a succinct answer. 1.01. What is the ratio of the Area (% of total land area) in Canada in 1998 to that in 2000?
Provide a succinct answer. 1. What is the ratio of the Area (% of total land area) of Nigeria in 1998 to that in 2000?
Your response must be concise. 0.98. What is the ratio of the Area (% of total land area) of Peru in 1998 to that in 2000?
Give a very brief answer. 0.98. What is the ratio of the Area (% of total land area) in Belarus in 1998 to that in 2001?
Make the answer very short. 1.02. What is the ratio of the Area (% of total land area) of Canada in 1998 to that in 2001?
Make the answer very short. 1. What is the ratio of the Area (% of total land area) in Peru in 1998 to that in 2001?
Provide a succinct answer. 0.98. What is the ratio of the Area (% of total land area) in Belarus in 1998 to that in 2002?
Keep it short and to the point. 1.03. What is the ratio of the Area (% of total land area) of Nigeria in 1998 to that in 2002?
Your answer should be very brief. 0.99. What is the ratio of the Area (% of total land area) of Belarus in 1998 to that in 2003?
Offer a very short reply. 1.04. What is the ratio of the Area (% of total land area) in Canada in 1998 to that in 2003?
Keep it short and to the point. 1. What is the ratio of the Area (% of total land area) in Nigeria in 1998 to that in 2003?
Provide a succinct answer. 0.97. What is the ratio of the Area (% of total land area) of Peru in 1998 to that in 2003?
Provide a short and direct response. 0.99. What is the ratio of the Area (% of total land area) of Belarus in 1998 to that in 2004?
Make the answer very short. 1.04. What is the ratio of the Area (% of total land area) in Nigeria in 1998 to that in 2004?
Give a very brief answer. 0.97. What is the ratio of the Area (% of total land area) of Peru in 1999 to that in 2000?
Your answer should be compact. 0.99. What is the ratio of the Area (% of total land area) of Belarus in 1999 to that in 2001?
Give a very brief answer. 1.02. What is the ratio of the Area (% of total land area) in Nigeria in 1999 to that in 2001?
Provide a succinct answer. 1.02. What is the ratio of the Area (% of total land area) of Belarus in 1999 to that in 2002?
Ensure brevity in your answer.  1.03. What is the ratio of the Area (% of total land area) of Nigeria in 1999 to that in 2002?
Keep it short and to the point. 1. What is the ratio of the Area (% of total land area) in Belarus in 1999 to that in 2003?
Your answer should be very brief. 1.03. What is the ratio of the Area (% of total land area) in Canada in 1999 to that in 2003?
Offer a terse response. 1. What is the ratio of the Area (% of total land area) in Belarus in 1999 to that in 2004?
Provide a succinct answer. 1.04. What is the ratio of the Area (% of total land area) in Nigeria in 1999 to that in 2004?
Give a very brief answer. 0.99. What is the ratio of the Area (% of total land area) of Belarus in 2000 to that in 2001?
Your answer should be compact. 1.01. What is the ratio of the Area (% of total land area) of Canada in 2000 to that in 2001?
Make the answer very short. 1. What is the ratio of the Area (% of total land area) in Nigeria in 2000 to that in 2001?
Give a very brief answer. 1.03. What is the ratio of the Area (% of total land area) in Belarus in 2000 to that in 2002?
Offer a terse response. 1.03. What is the ratio of the Area (% of total land area) in Canada in 2000 to that in 2002?
Your answer should be very brief. 1. What is the ratio of the Area (% of total land area) of Nigeria in 2000 to that in 2002?
Your response must be concise. 1.01. What is the ratio of the Area (% of total land area) in Peru in 2000 to that in 2002?
Give a very brief answer. 1.02. What is the ratio of the Area (% of total land area) in Belarus in 2000 to that in 2003?
Provide a short and direct response. 1.03. What is the ratio of the Area (% of total land area) in Canada in 2000 to that in 2003?
Give a very brief answer. 1. What is the ratio of the Area (% of total land area) in Nigeria in 2000 to that in 2003?
Keep it short and to the point. 0.99. What is the ratio of the Area (% of total land area) of Peru in 2000 to that in 2003?
Offer a very short reply. 1.01. What is the ratio of the Area (% of total land area) of Belarus in 2000 to that in 2004?
Make the answer very short. 1.03. What is the ratio of the Area (% of total land area) in Canada in 2000 to that in 2004?
Provide a succinct answer. 1. What is the ratio of the Area (% of total land area) in Nigeria in 2000 to that in 2004?
Ensure brevity in your answer.  0.99. What is the ratio of the Area (% of total land area) in Peru in 2000 to that in 2004?
Give a very brief answer. 1.01. What is the ratio of the Area (% of total land area) in Belarus in 2001 to that in 2002?
Your answer should be very brief. 1.01. What is the ratio of the Area (% of total land area) of Nigeria in 2001 to that in 2002?
Your response must be concise. 0.98. What is the ratio of the Area (% of total land area) of Peru in 2001 to that in 2002?
Your answer should be compact. 1.02. What is the ratio of the Area (% of total land area) of Belarus in 2001 to that in 2003?
Give a very brief answer. 1.02. What is the ratio of the Area (% of total land area) in Canada in 2001 to that in 2003?
Offer a terse response. 1. What is the ratio of the Area (% of total land area) of Nigeria in 2001 to that in 2003?
Provide a short and direct response. 0.97. What is the ratio of the Area (% of total land area) of Peru in 2001 to that in 2003?
Give a very brief answer. 1.01. What is the ratio of the Area (% of total land area) of Belarus in 2001 to that in 2004?
Make the answer very short. 1.02. What is the ratio of the Area (% of total land area) in Peru in 2001 to that in 2004?
Keep it short and to the point. 1.01. What is the ratio of the Area (% of total land area) in Belarus in 2002 to that in 2003?
Your answer should be very brief. 1. What is the ratio of the Area (% of total land area) in Peru in 2002 to that in 2003?
Give a very brief answer. 0.99. What is the ratio of the Area (% of total land area) in Belarus in 2002 to that in 2004?
Offer a very short reply. 1.01. What is the ratio of the Area (% of total land area) in Canada in 2002 to that in 2004?
Keep it short and to the point. 1. What is the ratio of the Area (% of total land area) in Nigeria in 2002 to that in 2004?
Offer a very short reply. 0.98. What is the ratio of the Area (% of total land area) of Peru in 2002 to that in 2004?
Give a very brief answer. 0.99. What is the ratio of the Area (% of total land area) in Canada in 2003 to that in 2004?
Offer a very short reply. 1. What is the ratio of the Area (% of total land area) of Nigeria in 2003 to that in 2004?
Ensure brevity in your answer.  1. What is the difference between the highest and the second highest Area (% of total land area) of Belarus?
Provide a short and direct response. 0. What is the difference between the highest and the second highest Area (% of total land area) in Canada?
Make the answer very short. 0.01. What is the difference between the highest and the second highest Area (% of total land area) in Nigeria?
Provide a succinct answer. 0.05. What is the difference between the highest and the second highest Area (% of total land area) of Peru?
Give a very brief answer. 0.01. What is the difference between the highest and the lowest Area (% of total land area) of Belarus?
Provide a succinct answer. 1.72. What is the difference between the highest and the lowest Area (% of total land area) in Canada?
Ensure brevity in your answer.  0.05. What is the difference between the highest and the lowest Area (% of total land area) of Nigeria?
Keep it short and to the point. 3.29. What is the difference between the highest and the lowest Area (% of total land area) of Peru?
Ensure brevity in your answer.  0.62. 